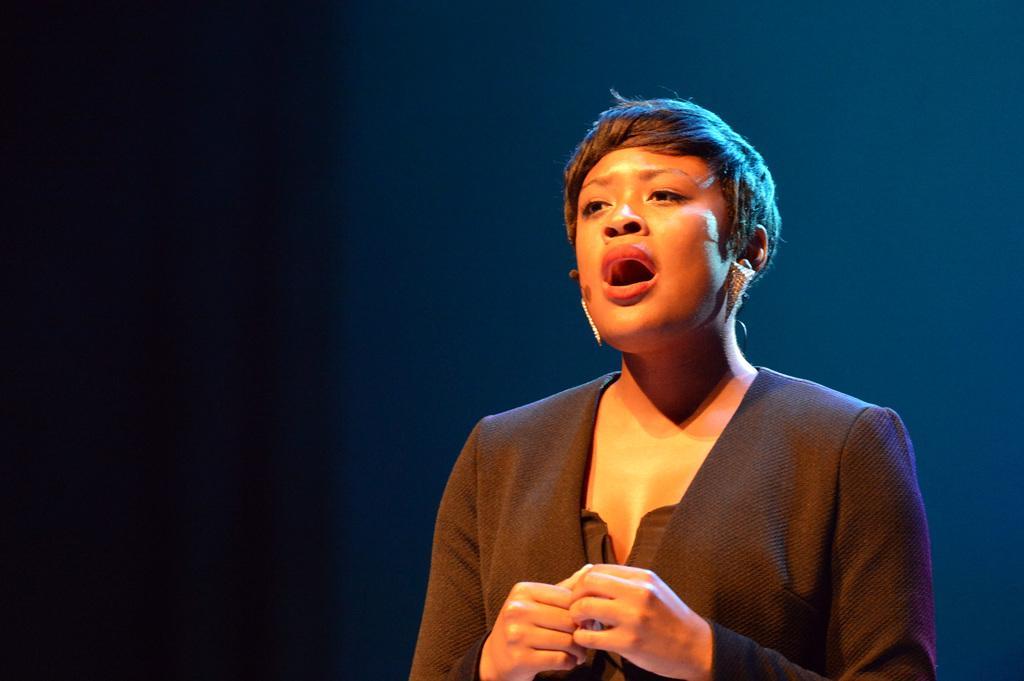Please provide a concise description of this image. There is one person standing and wearing a black color blazer on the right side of this image. 